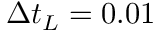Convert formula to latex. <formula><loc_0><loc_0><loc_500><loc_500>\Delta t _ { L } = 0 . 0 1</formula> 